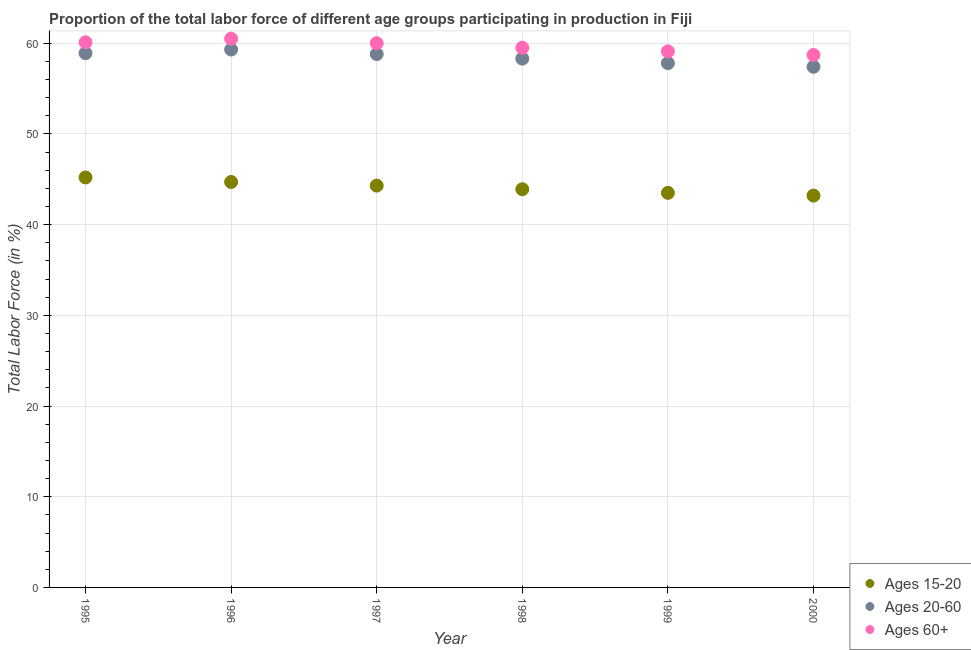How many different coloured dotlines are there?
Give a very brief answer. 3. What is the percentage of labor force within the age group 15-20 in 2000?
Your answer should be very brief. 43.2. Across all years, what is the maximum percentage of labor force above age 60?
Your answer should be compact. 60.5. Across all years, what is the minimum percentage of labor force above age 60?
Offer a terse response. 58.7. In which year was the percentage of labor force within the age group 20-60 maximum?
Ensure brevity in your answer.  1996. What is the total percentage of labor force within the age group 20-60 in the graph?
Provide a succinct answer. 350.5. What is the difference between the percentage of labor force within the age group 20-60 in 1995 and that in 1998?
Make the answer very short. 0.6. What is the difference between the percentage of labor force within the age group 20-60 in 2000 and the percentage of labor force above age 60 in 1995?
Give a very brief answer. -2.7. What is the average percentage of labor force above age 60 per year?
Your answer should be very brief. 59.65. In the year 1997, what is the difference between the percentage of labor force within the age group 15-20 and percentage of labor force above age 60?
Ensure brevity in your answer.  -15.7. What is the ratio of the percentage of labor force above age 60 in 1996 to that in 1998?
Make the answer very short. 1.02. Is the percentage of labor force above age 60 in 1997 less than that in 2000?
Your answer should be compact. No. What is the difference between the highest and the second highest percentage of labor force within the age group 20-60?
Offer a very short reply. 0.4. Does the percentage of labor force within the age group 15-20 monotonically increase over the years?
Your response must be concise. No. Is the percentage of labor force above age 60 strictly less than the percentage of labor force within the age group 20-60 over the years?
Keep it short and to the point. No. How many dotlines are there?
Offer a terse response. 3. Are the values on the major ticks of Y-axis written in scientific E-notation?
Make the answer very short. No. Does the graph contain any zero values?
Provide a short and direct response. No. Does the graph contain grids?
Ensure brevity in your answer.  Yes. What is the title of the graph?
Keep it short and to the point. Proportion of the total labor force of different age groups participating in production in Fiji. Does "Ages 15-64" appear as one of the legend labels in the graph?
Ensure brevity in your answer.  No. What is the label or title of the X-axis?
Offer a terse response. Year. What is the Total Labor Force (in %) in Ages 15-20 in 1995?
Offer a terse response. 45.2. What is the Total Labor Force (in %) in Ages 20-60 in 1995?
Your answer should be compact. 58.9. What is the Total Labor Force (in %) of Ages 60+ in 1995?
Ensure brevity in your answer.  60.1. What is the Total Labor Force (in %) in Ages 15-20 in 1996?
Offer a terse response. 44.7. What is the Total Labor Force (in %) of Ages 20-60 in 1996?
Your response must be concise. 59.3. What is the Total Labor Force (in %) in Ages 60+ in 1996?
Offer a very short reply. 60.5. What is the Total Labor Force (in %) in Ages 15-20 in 1997?
Provide a succinct answer. 44.3. What is the Total Labor Force (in %) in Ages 20-60 in 1997?
Provide a short and direct response. 58.8. What is the Total Labor Force (in %) in Ages 15-20 in 1998?
Offer a terse response. 43.9. What is the Total Labor Force (in %) of Ages 20-60 in 1998?
Provide a succinct answer. 58.3. What is the Total Labor Force (in %) of Ages 60+ in 1998?
Ensure brevity in your answer.  59.5. What is the Total Labor Force (in %) in Ages 15-20 in 1999?
Give a very brief answer. 43.5. What is the Total Labor Force (in %) in Ages 20-60 in 1999?
Provide a succinct answer. 57.8. What is the Total Labor Force (in %) of Ages 60+ in 1999?
Your response must be concise. 59.1. What is the Total Labor Force (in %) in Ages 15-20 in 2000?
Your response must be concise. 43.2. What is the Total Labor Force (in %) of Ages 20-60 in 2000?
Provide a succinct answer. 57.4. What is the Total Labor Force (in %) of Ages 60+ in 2000?
Provide a succinct answer. 58.7. Across all years, what is the maximum Total Labor Force (in %) of Ages 15-20?
Give a very brief answer. 45.2. Across all years, what is the maximum Total Labor Force (in %) of Ages 20-60?
Offer a very short reply. 59.3. Across all years, what is the maximum Total Labor Force (in %) in Ages 60+?
Provide a succinct answer. 60.5. Across all years, what is the minimum Total Labor Force (in %) of Ages 15-20?
Your answer should be very brief. 43.2. Across all years, what is the minimum Total Labor Force (in %) of Ages 20-60?
Offer a very short reply. 57.4. Across all years, what is the minimum Total Labor Force (in %) of Ages 60+?
Your response must be concise. 58.7. What is the total Total Labor Force (in %) of Ages 15-20 in the graph?
Provide a succinct answer. 264.8. What is the total Total Labor Force (in %) in Ages 20-60 in the graph?
Provide a succinct answer. 350.5. What is the total Total Labor Force (in %) of Ages 60+ in the graph?
Your answer should be very brief. 357.9. What is the difference between the Total Labor Force (in %) in Ages 15-20 in 1995 and that in 1996?
Offer a terse response. 0.5. What is the difference between the Total Labor Force (in %) in Ages 15-20 in 1995 and that in 1997?
Ensure brevity in your answer.  0.9. What is the difference between the Total Labor Force (in %) of Ages 20-60 in 1995 and that in 1997?
Offer a very short reply. 0.1. What is the difference between the Total Labor Force (in %) in Ages 60+ in 1995 and that in 1997?
Your response must be concise. 0.1. What is the difference between the Total Labor Force (in %) of Ages 20-60 in 1995 and that in 1998?
Give a very brief answer. 0.6. What is the difference between the Total Labor Force (in %) in Ages 20-60 in 1995 and that in 1999?
Provide a succinct answer. 1.1. What is the difference between the Total Labor Force (in %) of Ages 60+ in 1995 and that in 1999?
Your answer should be compact. 1. What is the difference between the Total Labor Force (in %) of Ages 15-20 in 1995 and that in 2000?
Offer a terse response. 2. What is the difference between the Total Labor Force (in %) in Ages 15-20 in 1996 and that in 1998?
Offer a very short reply. 0.8. What is the difference between the Total Labor Force (in %) of Ages 60+ in 1996 and that in 1998?
Offer a terse response. 1. What is the difference between the Total Labor Force (in %) of Ages 15-20 in 1996 and that in 2000?
Your response must be concise. 1.5. What is the difference between the Total Labor Force (in %) in Ages 60+ in 1996 and that in 2000?
Provide a succinct answer. 1.8. What is the difference between the Total Labor Force (in %) in Ages 15-20 in 1997 and that in 1998?
Provide a short and direct response. 0.4. What is the difference between the Total Labor Force (in %) in Ages 60+ in 1997 and that in 1998?
Offer a terse response. 0.5. What is the difference between the Total Labor Force (in %) of Ages 60+ in 1997 and that in 1999?
Provide a short and direct response. 0.9. What is the difference between the Total Labor Force (in %) in Ages 60+ in 1997 and that in 2000?
Offer a very short reply. 1.3. What is the difference between the Total Labor Force (in %) in Ages 15-20 in 1998 and that in 1999?
Your answer should be compact. 0.4. What is the difference between the Total Labor Force (in %) of Ages 60+ in 1998 and that in 1999?
Your answer should be very brief. 0.4. What is the difference between the Total Labor Force (in %) in Ages 15-20 in 1998 and that in 2000?
Ensure brevity in your answer.  0.7. What is the difference between the Total Labor Force (in %) of Ages 60+ in 1998 and that in 2000?
Your answer should be very brief. 0.8. What is the difference between the Total Labor Force (in %) of Ages 15-20 in 1999 and that in 2000?
Offer a terse response. 0.3. What is the difference between the Total Labor Force (in %) in Ages 60+ in 1999 and that in 2000?
Give a very brief answer. 0.4. What is the difference between the Total Labor Force (in %) in Ages 15-20 in 1995 and the Total Labor Force (in %) in Ages 20-60 in 1996?
Offer a terse response. -14.1. What is the difference between the Total Labor Force (in %) in Ages 15-20 in 1995 and the Total Labor Force (in %) in Ages 60+ in 1996?
Provide a short and direct response. -15.3. What is the difference between the Total Labor Force (in %) in Ages 15-20 in 1995 and the Total Labor Force (in %) in Ages 20-60 in 1997?
Make the answer very short. -13.6. What is the difference between the Total Labor Force (in %) in Ages 15-20 in 1995 and the Total Labor Force (in %) in Ages 60+ in 1997?
Ensure brevity in your answer.  -14.8. What is the difference between the Total Labor Force (in %) of Ages 20-60 in 1995 and the Total Labor Force (in %) of Ages 60+ in 1997?
Your answer should be compact. -1.1. What is the difference between the Total Labor Force (in %) in Ages 15-20 in 1995 and the Total Labor Force (in %) in Ages 20-60 in 1998?
Offer a very short reply. -13.1. What is the difference between the Total Labor Force (in %) in Ages 15-20 in 1995 and the Total Labor Force (in %) in Ages 60+ in 1998?
Make the answer very short. -14.3. What is the difference between the Total Labor Force (in %) of Ages 20-60 in 1995 and the Total Labor Force (in %) of Ages 60+ in 1998?
Offer a terse response. -0.6. What is the difference between the Total Labor Force (in %) in Ages 15-20 in 1995 and the Total Labor Force (in %) in Ages 20-60 in 1999?
Your response must be concise. -12.6. What is the difference between the Total Labor Force (in %) of Ages 20-60 in 1995 and the Total Labor Force (in %) of Ages 60+ in 1999?
Provide a succinct answer. -0.2. What is the difference between the Total Labor Force (in %) of Ages 15-20 in 1995 and the Total Labor Force (in %) of Ages 60+ in 2000?
Keep it short and to the point. -13.5. What is the difference between the Total Labor Force (in %) in Ages 15-20 in 1996 and the Total Labor Force (in %) in Ages 20-60 in 1997?
Offer a very short reply. -14.1. What is the difference between the Total Labor Force (in %) of Ages 15-20 in 1996 and the Total Labor Force (in %) of Ages 60+ in 1997?
Provide a succinct answer. -15.3. What is the difference between the Total Labor Force (in %) in Ages 20-60 in 1996 and the Total Labor Force (in %) in Ages 60+ in 1997?
Your response must be concise. -0.7. What is the difference between the Total Labor Force (in %) of Ages 15-20 in 1996 and the Total Labor Force (in %) of Ages 20-60 in 1998?
Provide a succinct answer. -13.6. What is the difference between the Total Labor Force (in %) in Ages 15-20 in 1996 and the Total Labor Force (in %) in Ages 60+ in 1998?
Your answer should be very brief. -14.8. What is the difference between the Total Labor Force (in %) in Ages 15-20 in 1996 and the Total Labor Force (in %) in Ages 20-60 in 1999?
Provide a succinct answer. -13.1. What is the difference between the Total Labor Force (in %) in Ages 15-20 in 1996 and the Total Labor Force (in %) in Ages 60+ in 1999?
Keep it short and to the point. -14.4. What is the difference between the Total Labor Force (in %) in Ages 20-60 in 1996 and the Total Labor Force (in %) in Ages 60+ in 1999?
Give a very brief answer. 0.2. What is the difference between the Total Labor Force (in %) of Ages 15-20 in 1997 and the Total Labor Force (in %) of Ages 20-60 in 1998?
Your answer should be compact. -14. What is the difference between the Total Labor Force (in %) of Ages 15-20 in 1997 and the Total Labor Force (in %) of Ages 60+ in 1998?
Your answer should be compact. -15.2. What is the difference between the Total Labor Force (in %) in Ages 15-20 in 1997 and the Total Labor Force (in %) in Ages 20-60 in 1999?
Keep it short and to the point. -13.5. What is the difference between the Total Labor Force (in %) in Ages 15-20 in 1997 and the Total Labor Force (in %) in Ages 60+ in 1999?
Your response must be concise. -14.8. What is the difference between the Total Labor Force (in %) in Ages 20-60 in 1997 and the Total Labor Force (in %) in Ages 60+ in 1999?
Your answer should be compact. -0.3. What is the difference between the Total Labor Force (in %) in Ages 15-20 in 1997 and the Total Labor Force (in %) in Ages 60+ in 2000?
Provide a short and direct response. -14.4. What is the difference between the Total Labor Force (in %) in Ages 20-60 in 1997 and the Total Labor Force (in %) in Ages 60+ in 2000?
Give a very brief answer. 0.1. What is the difference between the Total Labor Force (in %) of Ages 15-20 in 1998 and the Total Labor Force (in %) of Ages 60+ in 1999?
Offer a very short reply. -15.2. What is the difference between the Total Labor Force (in %) in Ages 20-60 in 1998 and the Total Labor Force (in %) in Ages 60+ in 1999?
Ensure brevity in your answer.  -0.8. What is the difference between the Total Labor Force (in %) of Ages 15-20 in 1998 and the Total Labor Force (in %) of Ages 20-60 in 2000?
Offer a terse response. -13.5. What is the difference between the Total Labor Force (in %) in Ages 15-20 in 1998 and the Total Labor Force (in %) in Ages 60+ in 2000?
Provide a short and direct response. -14.8. What is the difference between the Total Labor Force (in %) in Ages 20-60 in 1998 and the Total Labor Force (in %) in Ages 60+ in 2000?
Provide a succinct answer. -0.4. What is the difference between the Total Labor Force (in %) of Ages 15-20 in 1999 and the Total Labor Force (in %) of Ages 20-60 in 2000?
Keep it short and to the point. -13.9. What is the difference between the Total Labor Force (in %) of Ages 15-20 in 1999 and the Total Labor Force (in %) of Ages 60+ in 2000?
Your answer should be compact. -15.2. What is the average Total Labor Force (in %) in Ages 15-20 per year?
Your response must be concise. 44.13. What is the average Total Labor Force (in %) of Ages 20-60 per year?
Offer a terse response. 58.42. What is the average Total Labor Force (in %) in Ages 60+ per year?
Your answer should be compact. 59.65. In the year 1995, what is the difference between the Total Labor Force (in %) in Ages 15-20 and Total Labor Force (in %) in Ages 20-60?
Your answer should be very brief. -13.7. In the year 1995, what is the difference between the Total Labor Force (in %) of Ages 15-20 and Total Labor Force (in %) of Ages 60+?
Offer a terse response. -14.9. In the year 1996, what is the difference between the Total Labor Force (in %) of Ages 15-20 and Total Labor Force (in %) of Ages 20-60?
Provide a short and direct response. -14.6. In the year 1996, what is the difference between the Total Labor Force (in %) in Ages 15-20 and Total Labor Force (in %) in Ages 60+?
Offer a terse response. -15.8. In the year 1996, what is the difference between the Total Labor Force (in %) of Ages 20-60 and Total Labor Force (in %) of Ages 60+?
Give a very brief answer. -1.2. In the year 1997, what is the difference between the Total Labor Force (in %) of Ages 15-20 and Total Labor Force (in %) of Ages 20-60?
Provide a succinct answer. -14.5. In the year 1997, what is the difference between the Total Labor Force (in %) in Ages 15-20 and Total Labor Force (in %) in Ages 60+?
Give a very brief answer. -15.7. In the year 1998, what is the difference between the Total Labor Force (in %) of Ages 15-20 and Total Labor Force (in %) of Ages 20-60?
Make the answer very short. -14.4. In the year 1998, what is the difference between the Total Labor Force (in %) in Ages 15-20 and Total Labor Force (in %) in Ages 60+?
Offer a terse response. -15.6. In the year 1999, what is the difference between the Total Labor Force (in %) of Ages 15-20 and Total Labor Force (in %) of Ages 20-60?
Give a very brief answer. -14.3. In the year 1999, what is the difference between the Total Labor Force (in %) of Ages 15-20 and Total Labor Force (in %) of Ages 60+?
Ensure brevity in your answer.  -15.6. In the year 1999, what is the difference between the Total Labor Force (in %) of Ages 20-60 and Total Labor Force (in %) of Ages 60+?
Keep it short and to the point. -1.3. In the year 2000, what is the difference between the Total Labor Force (in %) of Ages 15-20 and Total Labor Force (in %) of Ages 20-60?
Ensure brevity in your answer.  -14.2. In the year 2000, what is the difference between the Total Labor Force (in %) in Ages 15-20 and Total Labor Force (in %) in Ages 60+?
Keep it short and to the point. -15.5. In the year 2000, what is the difference between the Total Labor Force (in %) in Ages 20-60 and Total Labor Force (in %) in Ages 60+?
Make the answer very short. -1.3. What is the ratio of the Total Labor Force (in %) of Ages 15-20 in 1995 to that in 1996?
Provide a succinct answer. 1.01. What is the ratio of the Total Labor Force (in %) of Ages 60+ in 1995 to that in 1996?
Your response must be concise. 0.99. What is the ratio of the Total Labor Force (in %) of Ages 15-20 in 1995 to that in 1997?
Provide a succinct answer. 1.02. What is the ratio of the Total Labor Force (in %) of Ages 20-60 in 1995 to that in 1997?
Offer a terse response. 1. What is the ratio of the Total Labor Force (in %) in Ages 60+ in 1995 to that in 1997?
Provide a short and direct response. 1. What is the ratio of the Total Labor Force (in %) in Ages 15-20 in 1995 to that in 1998?
Offer a very short reply. 1.03. What is the ratio of the Total Labor Force (in %) of Ages 20-60 in 1995 to that in 1998?
Provide a short and direct response. 1.01. What is the ratio of the Total Labor Force (in %) in Ages 60+ in 1995 to that in 1998?
Provide a short and direct response. 1.01. What is the ratio of the Total Labor Force (in %) in Ages 15-20 in 1995 to that in 1999?
Offer a very short reply. 1.04. What is the ratio of the Total Labor Force (in %) in Ages 60+ in 1995 to that in 1999?
Your response must be concise. 1.02. What is the ratio of the Total Labor Force (in %) of Ages 15-20 in 1995 to that in 2000?
Give a very brief answer. 1.05. What is the ratio of the Total Labor Force (in %) of Ages 20-60 in 1995 to that in 2000?
Provide a short and direct response. 1.03. What is the ratio of the Total Labor Force (in %) of Ages 60+ in 1995 to that in 2000?
Offer a very short reply. 1.02. What is the ratio of the Total Labor Force (in %) of Ages 15-20 in 1996 to that in 1997?
Ensure brevity in your answer.  1.01. What is the ratio of the Total Labor Force (in %) in Ages 20-60 in 1996 to that in 1997?
Your response must be concise. 1.01. What is the ratio of the Total Labor Force (in %) in Ages 60+ in 1996 to that in 1997?
Keep it short and to the point. 1.01. What is the ratio of the Total Labor Force (in %) in Ages 15-20 in 1996 to that in 1998?
Give a very brief answer. 1.02. What is the ratio of the Total Labor Force (in %) of Ages 20-60 in 1996 to that in 1998?
Your response must be concise. 1.02. What is the ratio of the Total Labor Force (in %) in Ages 60+ in 1996 to that in 1998?
Keep it short and to the point. 1.02. What is the ratio of the Total Labor Force (in %) of Ages 15-20 in 1996 to that in 1999?
Your answer should be very brief. 1.03. What is the ratio of the Total Labor Force (in %) in Ages 60+ in 1996 to that in 1999?
Give a very brief answer. 1.02. What is the ratio of the Total Labor Force (in %) of Ages 15-20 in 1996 to that in 2000?
Your answer should be compact. 1.03. What is the ratio of the Total Labor Force (in %) of Ages 20-60 in 1996 to that in 2000?
Ensure brevity in your answer.  1.03. What is the ratio of the Total Labor Force (in %) in Ages 60+ in 1996 to that in 2000?
Give a very brief answer. 1.03. What is the ratio of the Total Labor Force (in %) of Ages 15-20 in 1997 to that in 1998?
Provide a succinct answer. 1.01. What is the ratio of the Total Labor Force (in %) of Ages 20-60 in 1997 to that in 1998?
Make the answer very short. 1.01. What is the ratio of the Total Labor Force (in %) in Ages 60+ in 1997 to that in 1998?
Provide a succinct answer. 1.01. What is the ratio of the Total Labor Force (in %) of Ages 15-20 in 1997 to that in 1999?
Provide a short and direct response. 1.02. What is the ratio of the Total Labor Force (in %) in Ages 20-60 in 1997 to that in 1999?
Ensure brevity in your answer.  1.02. What is the ratio of the Total Labor Force (in %) in Ages 60+ in 1997 to that in 1999?
Keep it short and to the point. 1.02. What is the ratio of the Total Labor Force (in %) of Ages 15-20 in 1997 to that in 2000?
Provide a succinct answer. 1.03. What is the ratio of the Total Labor Force (in %) in Ages 20-60 in 1997 to that in 2000?
Your response must be concise. 1.02. What is the ratio of the Total Labor Force (in %) of Ages 60+ in 1997 to that in 2000?
Your answer should be very brief. 1.02. What is the ratio of the Total Labor Force (in %) of Ages 15-20 in 1998 to that in 1999?
Ensure brevity in your answer.  1.01. What is the ratio of the Total Labor Force (in %) in Ages 20-60 in 1998 to that in 1999?
Keep it short and to the point. 1.01. What is the ratio of the Total Labor Force (in %) of Ages 60+ in 1998 to that in 1999?
Provide a succinct answer. 1.01. What is the ratio of the Total Labor Force (in %) in Ages 15-20 in 1998 to that in 2000?
Give a very brief answer. 1.02. What is the ratio of the Total Labor Force (in %) of Ages 20-60 in 1998 to that in 2000?
Give a very brief answer. 1.02. What is the ratio of the Total Labor Force (in %) of Ages 60+ in 1998 to that in 2000?
Ensure brevity in your answer.  1.01. What is the ratio of the Total Labor Force (in %) in Ages 15-20 in 1999 to that in 2000?
Offer a very short reply. 1.01. What is the ratio of the Total Labor Force (in %) of Ages 60+ in 1999 to that in 2000?
Offer a terse response. 1.01. What is the difference between the highest and the second highest Total Labor Force (in %) in Ages 60+?
Your answer should be very brief. 0.4. What is the difference between the highest and the lowest Total Labor Force (in %) of Ages 20-60?
Offer a terse response. 1.9. What is the difference between the highest and the lowest Total Labor Force (in %) of Ages 60+?
Keep it short and to the point. 1.8. 